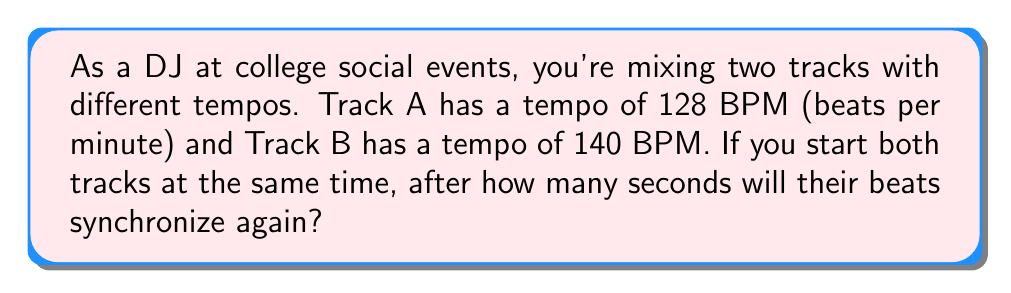Can you solve this math problem? To solve this problem, we need to find the least common multiple (LCM) of the beat durations for both tracks. Let's approach this step-by-step:

1) First, calculate the duration of one beat for each track:
   Track A: $\frac{60 \text{ seconds}}{128 \text{ beats}} = \frac{15}{32} \text{ seconds per beat}$
   Track B: $\frac{60 \text{ seconds}}{140 \text{ beats}} = \frac{3}{7} \text{ seconds per beat}$

2) To find when the beats will synchronize, we need to find the LCM of these durations:
   $LCM(\frac{15}{32}, \frac{3}{7})$

3) To calculate the LCM, first find the LCM of the numerators and the LCD of the denominators:
   $LCM(15, 3) = 15$
   $LCD(32, 7) = 224$

4) The LCM of the fractions is then:
   $\frac{15}{224} \text{ seconds}$

5) To find how many seconds until synchronization, we need to find how many of these intervals occur in one minute:
   $\frac{60 \text{ seconds}}{\frac{15}{224} \text{ seconds}} = 896$

Therefore, the beats will synchronize after 896 intervals of $\frac{15}{224}$ seconds.

6) Calculate the total time:
   $896 \times \frac{15}{224} = 60 \text{ seconds}$
Answer: The beats of the two tracks will synchronize again after 60 seconds. 